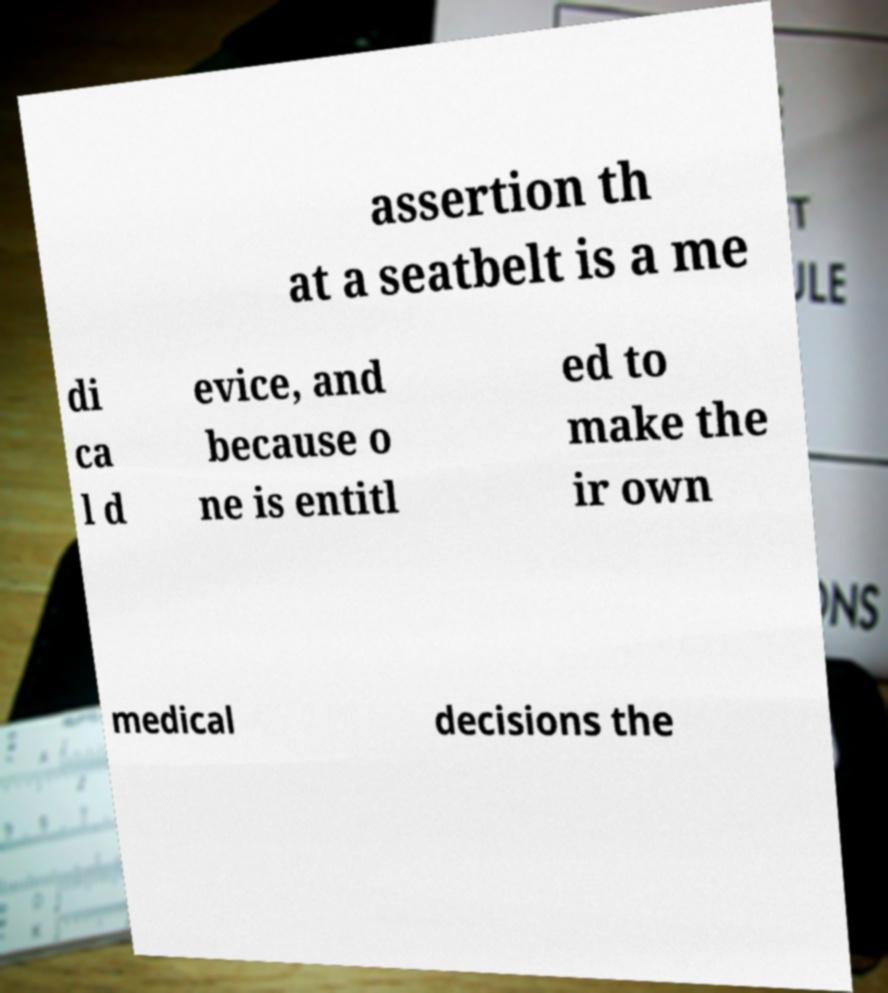There's text embedded in this image that I need extracted. Can you transcribe it verbatim? assertion th at a seatbelt is a me di ca l d evice, and because o ne is entitl ed to make the ir own medical decisions the 